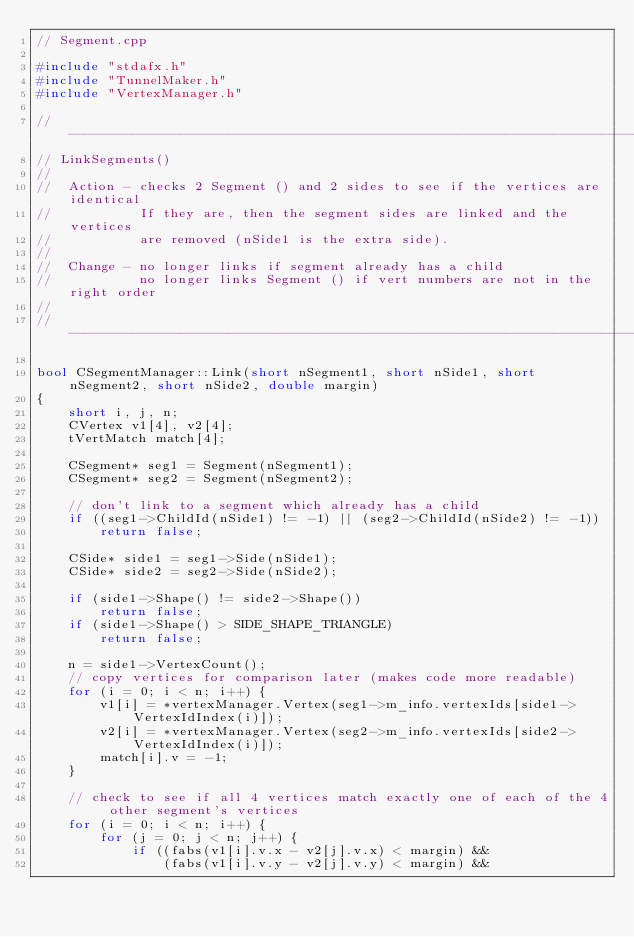<code> <loc_0><loc_0><loc_500><loc_500><_C++_>// Segment.cpp

#include "stdafx.h"
#include "TunnelMaker.h"
#include "VertexManager.h"

// ----------------------------------------------------------------------------- 
// LinkSegments()
//
//  Action - checks 2 Segment () and 2 sides to see if the vertices are identical
//           If they are, then the segment sides are linked and the vertices
//           are removed (nSide1 is the extra side).
//
//  Change - no longer links if segment already has a child
//           no longer links Segment () if vert numbers are not in the right order
//
// ----------------------------------------------------------------------------- 

bool CSegmentManager::Link(short nSegment1, short nSide1, short nSegment2, short nSide2, double margin)
{
    short i, j, n;
    CVertex v1[4], v2[4];
    tVertMatch match[4];

    CSegment* seg1 = Segment(nSegment1);
    CSegment* seg2 = Segment(nSegment2);

    // don't link to a segment which already has a child
    if ((seg1->ChildId(nSide1) != -1) || (seg2->ChildId(nSide2) != -1))
        return false;

    CSide* side1 = seg1->Side(nSide1);
    CSide* side2 = seg2->Side(nSide2);

    if (side1->Shape() != side2->Shape())
        return false;
    if (side1->Shape() > SIDE_SHAPE_TRIANGLE)
        return false;

    n = side1->VertexCount();
    // copy vertices for comparison later (makes code more readable)
    for (i = 0; i < n; i++) {
        v1[i] = *vertexManager.Vertex(seg1->m_info.vertexIds[side1->VertexIdIndex(i)]);
        v2[i] = *vertexManager.Vertex(seg2->m_info.vertexIds[side2->VertexIdIndex(i)]);
        match[i].v = -1;
    }

    // check to see if all 4 vertices match exactly one of each of the 4 other segment's vertices
    for (i = 0; i < n; i++) {
        for (j = 0; j < n; j++) {
            if ((fabs(v1[i].v.x - v2[j].v.x) < margin) &&
                (fabs(v1[i].v.y - v2[j].v.y) < margin) &&</code> 